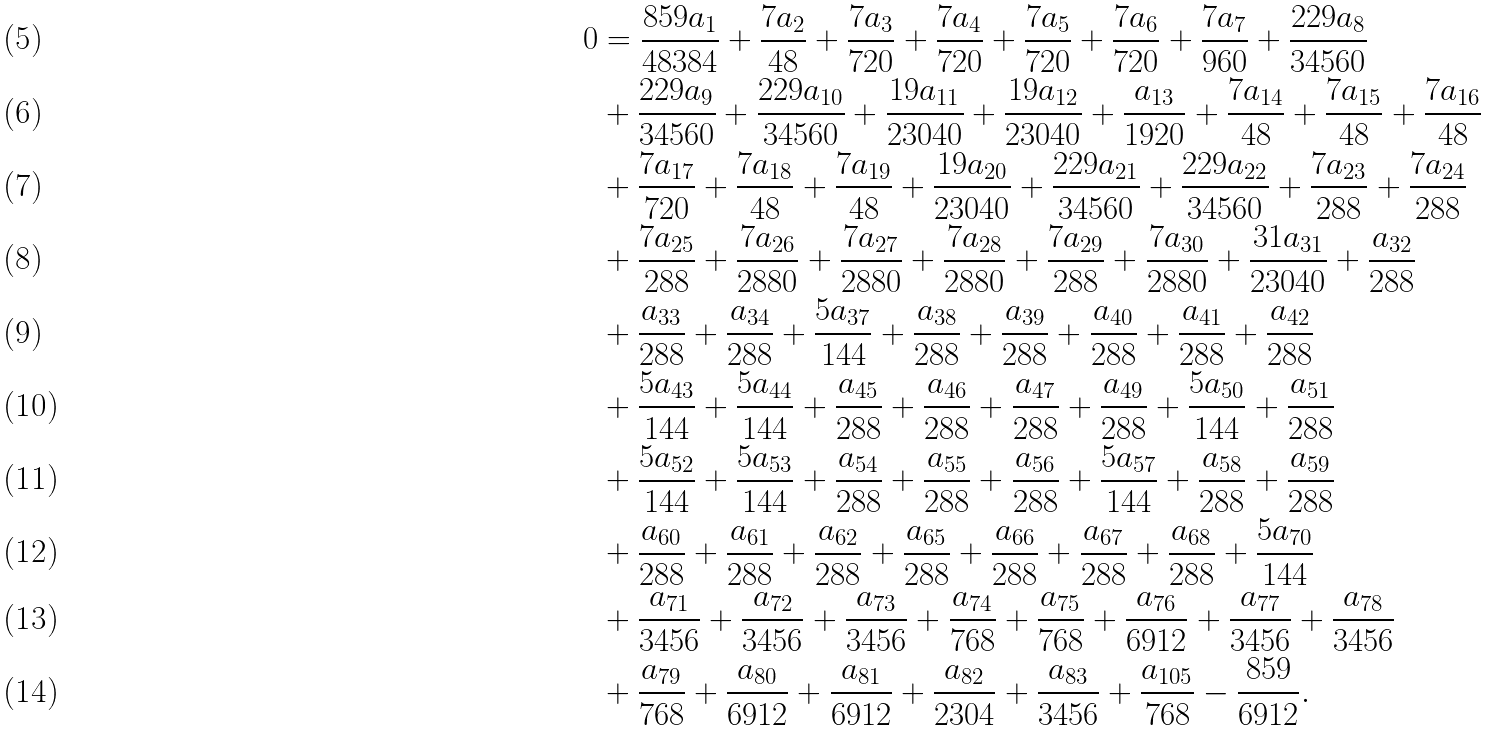<formula> <loc_0><loc_0><loc_500><loc_500>0 & = \frac { 8 5 9 a _ { 1 } } { 4 8 3 8 4 } + \frac { 7 a _ { 2 } } { 4 8 } + \frac { 7 a _ { 3 } } { 7 2 0 } + \frac { 7 a _ { 4 } } { 7 2 0 } + \frac { 7 a _ { 5 } } { 7 2 0 } + \frac { 7 a _ { 6 } } { 7 2 0 } + \frac { 7 a _ { 7 } } { 9 6 0 } + \frac { 2 2 9 a _ { 8 } } { 3 4 5 6 0 } \\ & + \frac { 2 2 9 a _ { 9 } } { 3 4 5 6 0 } + \frac { 2 2 9 a _ { 1 0 } } { 3 4 5 6 0 } + \frac { 1 9 a _ { 1 1 } } { 2 3 0 4 0 } + \frac { 1 9 a _ { 1 2 } } { 2 3 0 4 0 } + \frac { a _ { 1 3 } } { 1 9 2 0 } + \frac { 7 a _ { 1 4 } } { 4 8 } + \frac { 7 a _ { 1 5 } } { 4 8 } + \frac { 7 a _ { 1 6 } } { 4 8 } \\ & + \frac { 7 a _ { 1 7 } } { 7 2 0 } + \frac { 7 a _ { 1 8 } } { 4 8 } + \frac { 7 a _ { 1 9 } } { 4 8 } + \frac { 1 9 a _ { 2 0 } } { 2 3 0 4 0 } + \frac { 2 2 9 a _ { 2 1 } } { 3 4 5 6 0 } + \frac { 2 2 9 a _ { 2 2 } } { 3 4 5 6 0 } + \frac { 7 a _ { 2 3 } } { 2 8 8 } + \frac { 7 a _ { 2 4 } } { 2 8 8 } \\ & + \frac { 7 a _ { 2 5 } } { 2 8 8 } + \frac { 7 a _ { 2 6 } } { 2 8 8 0 } + \frac { 7 a _ { 2 7 } } { 2 8 8 0 } + \frac { 7 a _ { 2 8 } } { 2 8 8 0 } + \frac { 7 a _ { 2 9 } } { 2 8 8 } + \frac { 7 a _ { 3 0 } } { 2 8 8 0 } + \frac { 3 1 a _ { 3 1 } } { 2 3 0 4 0 } + \frac { a _ { 3 2 } } { 2 8 8 } \\ & + \frac { a _ { 3 3 } } { 2 8 8 } + \frac { a _ { 3 4 } } { 2 8 8 } + \frac { 5 a _ { 3 7 } } { 1 4 4 } + \frac { a _ { 3 8 } } { 2 8 8 } + \frac { a _ { 3 9 } } { 2 8 8 } + \frac { a _ { 4 0 } } { 2 8 8 } + \frac { a _ { 4 1 } } { 2 8 8 } + \frac { a _ { 4 2 } } { 2 8 8 } \\ & + \frac { 5 a _ { 4 3 } } { 1 4 4 } + \frac { 5 a _ { 4 4 } } { 1 4 4 } + \frac { a _ { 4 5 } } { 2 8 8 } + \frac { a _ { 4 6 } } { 2 8 8 } + \frac { a _ { 4 7 } } { 2 8 8 } + \frac { a _ { 4 9 } } { 2 8 8 } + \frac { 5 a _ { 5 0 } } { 1 4 4 } + \frac { a _ { 5 1 } } { 2 8 8 } \\ & + \frac { 5 a _ { 5 2 } } { 1 4 4 } + \frac { 5 a _ { 5 3 } } { 1 4 4 } + \frac { a _ { 5 4 } } { 2 8 8 } + \frac { a _ { 5 5 } } { 2 8 8 } + \frac { a _ { 5 6 } } { 2 8 8 } + \frac { 5 a _ { 5 7 } } { 1 4 4 } + \frac { a _ { 5 8 } } { 2 8 8 } + \frac { a _ { 5 9 } } { 2 8 8 } \\ & + \frac { a _ { 6 0 } } { 2 8 8 } + \frac { a _ { 6 1 } } { 2 8 8 } + \frac { a _ { 6 2 } } { 2 8 8 } + \frac { a _ { 6 5 } } { 2 8 8 } + \frac { a _ { 6 6 } } { 2 8 8 } + \frac { a _ { 6 7 } } { 2 8 8 } + \frac { a _ { 6 8 } } { 2 8 8 } + \frac { 5 a _ { 7 0 } } { 1 4 4 } \\ & + \frac { a _ { 7 1 } } { 3 4 5 6 } + \frac { a _ { 7 2 } } { 3 4 5 6 } + \frac { a _ { 7 3 } } { 3 4 5 6 } + \frac { a _ { 7 4 } } { 7 6 8 } + \frac { a _ { 7 5 } } { 7 6 8 } + \frac { a _ { 7 6 } } { 6 9 1 2 } + \frac { a _ { 7 7 } } { 3 4 5 6 } + \frac { a _ { 7 8 } } { 3 4 5 6 } \\ & + \frac { a _ { 7 9 } } { 7 6 8 } + \frac { a _ { 8 0 } } { 6 9 1 2 } + \frac { a _ { 8 1 } } { 6 9 1 2 } + \frac { a _ { 8 2 } } { 2 3 0 4 } + \frac { a _ { 8 3 } } { 3 4 5 6 } + \frac { a _ { 1 0 5 } } { 7 6 8 } - \frac { 8 5 9 } { 6 9 1 2 } .</formula> 